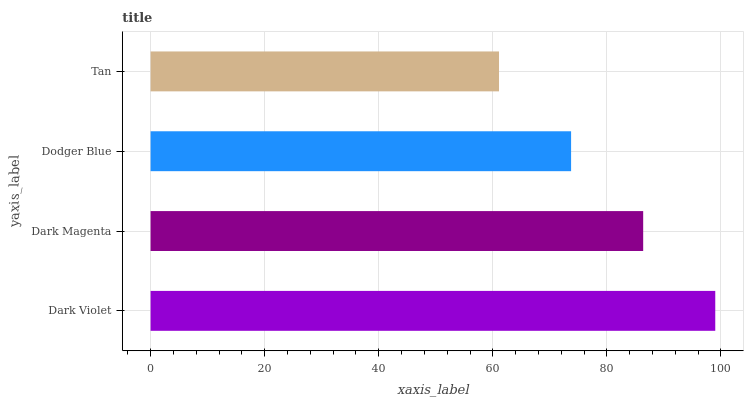Is Tan the minimum?
Answer yes or no. Yes. Is Dark Violet the maximum?
Answer yes or no. Yes. Is Dark Magenta the minimum?
Answer yes or no. No. Is Dark Magenta the maximum?
Answer yes or no. No. Is Dark Violet greater than Dark Magenta?
Answer yes or no. Yes. Is Dark Magenta less than Dark Violet?
Answer yes or no. Yes. Is Dark Magenta greater than Dark Violet?
Answer yes or no. No. Is Dark Violet less than Dark Magenta?
Answer yes or no. No. Is Dark Magenta the high median?
Answer yes or no. Yes. Is Dodger Blue the low median?
Answer yes or no. Yes. Is Tan the high median?
Answer yes or no. No. Is Dark Violet the low median?
Answer yes or no. No. 